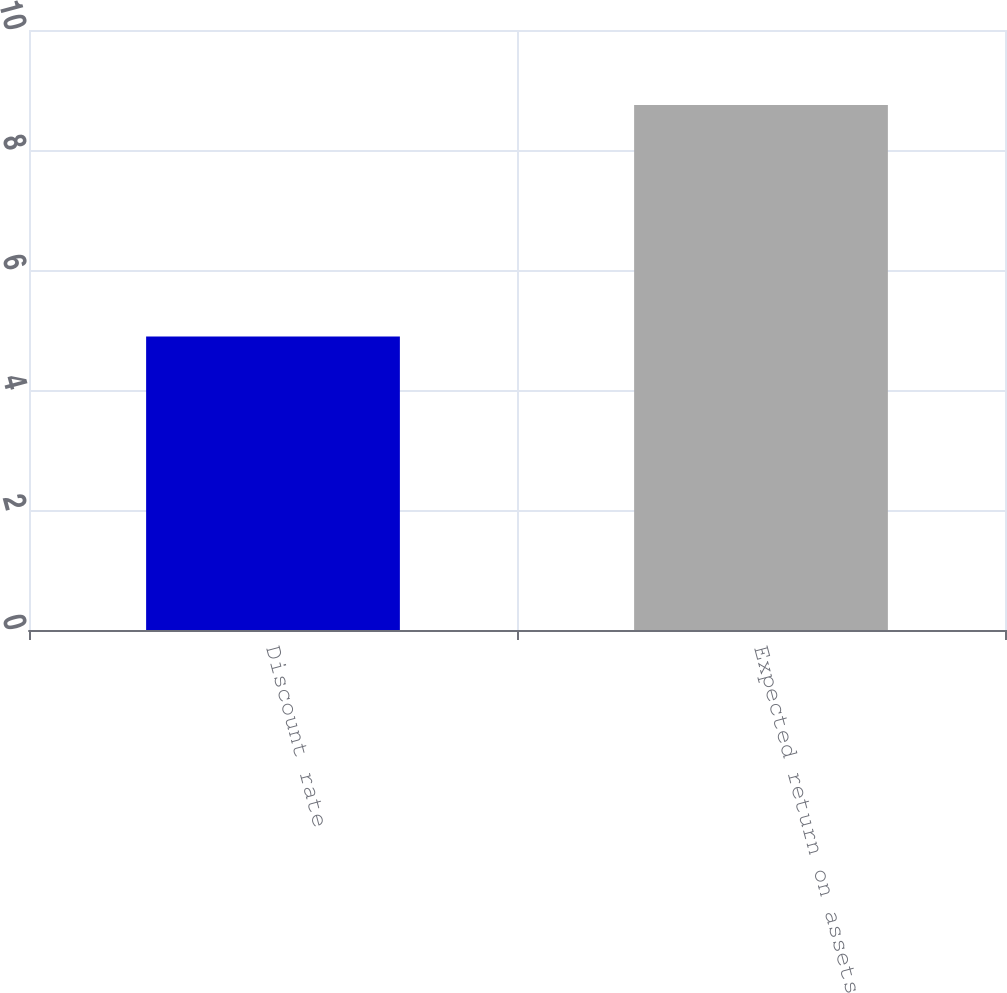<chart> <loc_0><loc_0><loc_500><loc_500><bar_chart><fcel>Discount rate<fcel>Expected return on assets<nl><fcel>4.89<fcel>8.75<nl></chart> 